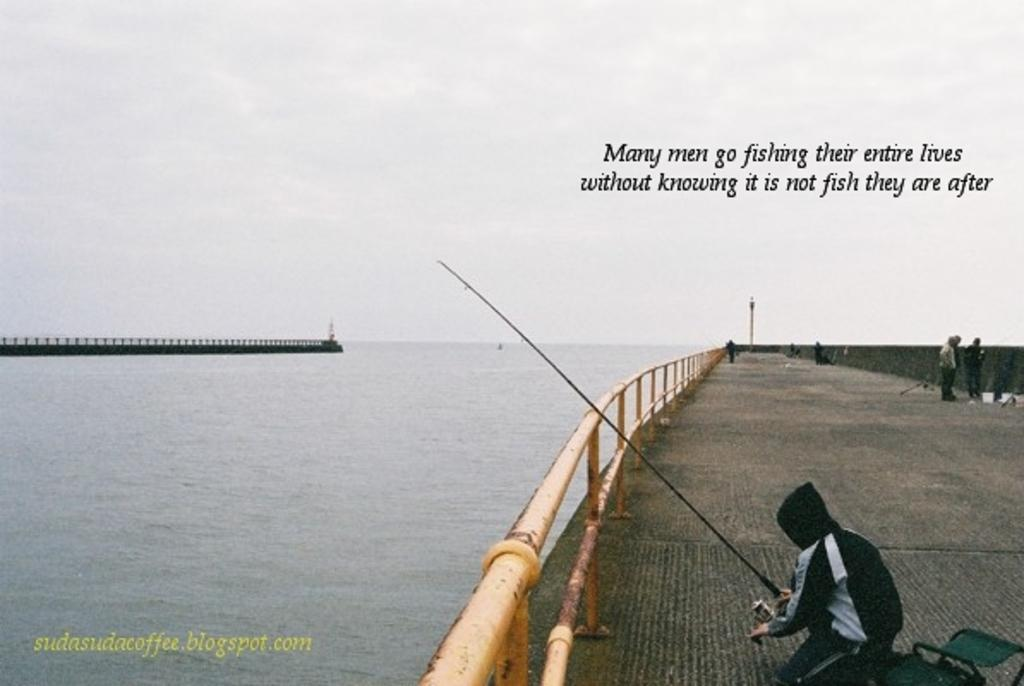What is the man doing on the right side of the image? The man is fishing. What is located on the left side of the image? There is water on the left side of the image. What is visible at the top of the image? The sky is visible at the top of the image. How would you describe the sky in the image? The sky appears to be cloudy. Where is the shop located in the image? There is no shop present in the image. What type of curve can be seen in the image? There is no curve visible in the image. 